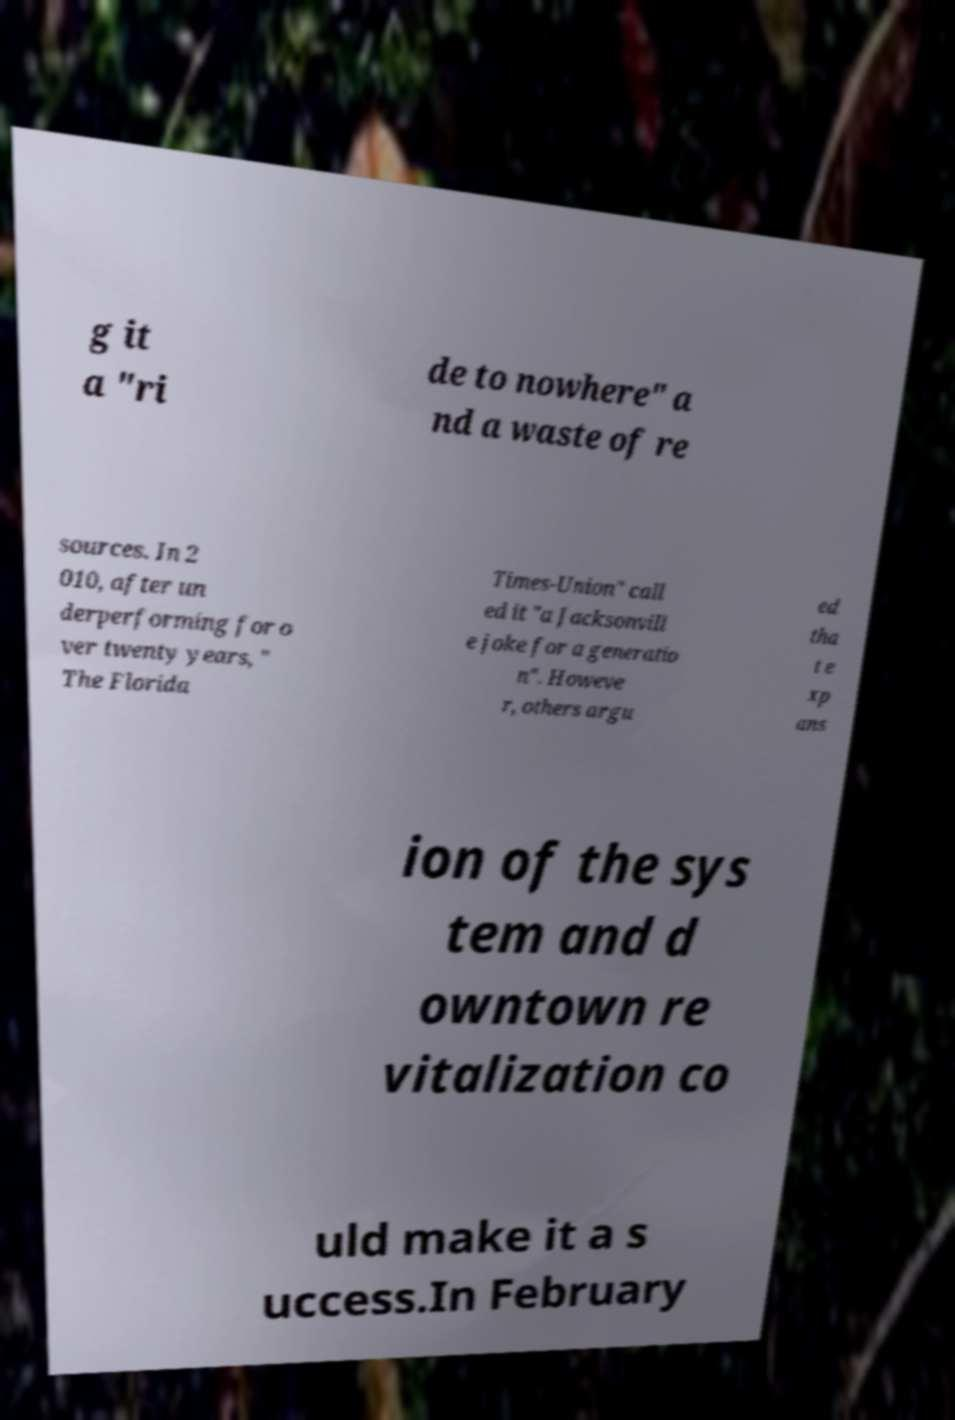What messages or text are displayed in this image? I need them in a readable, typed format. g it a "ri de to nowhere" a nd a waste of re sources. In 2 010, after un derperforming for o ver twenty years, " The Florida Times-Union" call ed it "a Jacksonvill e joke for a generatio n". Howeve r, others argu ed tha t e xp ans ion of the sys tem and d owntown re vitalization co uld make it a s uccess.In February 